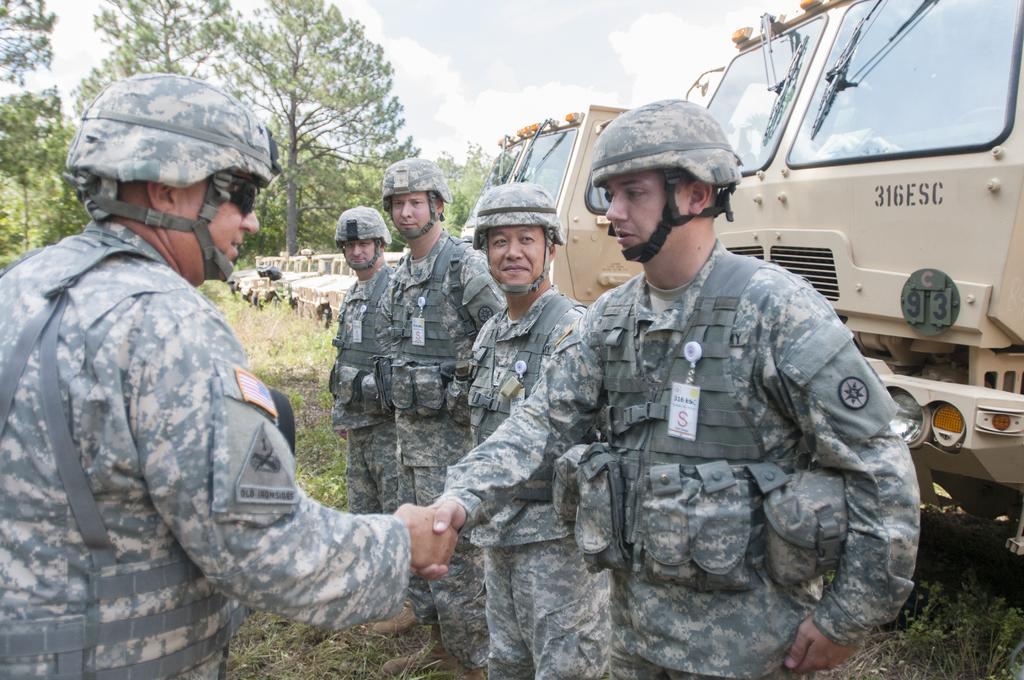What red letter is on the badge?
Keep it short and to the point. S. What is the vehicle behind the soldiers id number?
Your response must be concise. 316esc. 